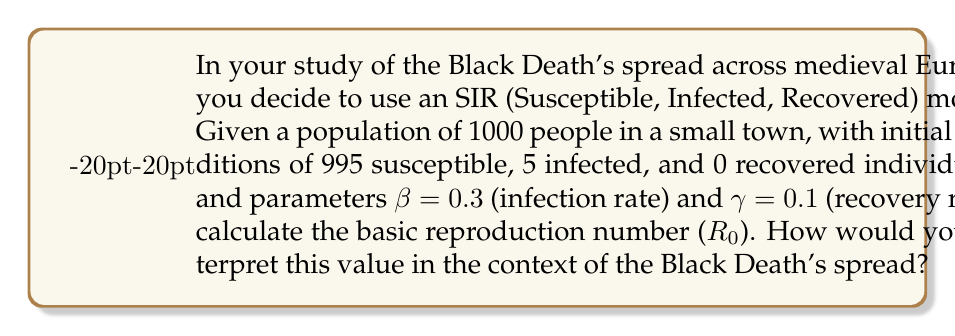Can you answer this question? To solve this problem, we'll follow these steps:

1. Understand the SIR model parameters:
   - S: Susceptible individuals
   - I: Infected individuals
   - R: Recovered individuals
   - β: Infection rate
   - γ: Recovery rate

2. Recall the formula for the basic reproduction number (R₀):
   $$ R_0 = \frac{\beta}{\gamma} $$

3. Insert the given values into the formula:
   $$ R_0 = \frac{0.3}{0.1} $$

4. Calculate R₀:
   $$ R_0 = 3 $$

5. Interpret the result:
   - R₀ > 1 indicates that the disease will spread exponentially.
   - R₀ = 3 means that, on average, each infected person will infect 3 new individuals during their infectious period.
   - This high R₀ value aligns with the historical rapid spread of the Black Death across Europe.
   - It suggests that without intervention, the disease would quickly spread through the population.
   - This model helps explain why the Black Death was so devastating and difficult to control in medieval times, given the lack of modern medical knowledge and interventions.
Answer: R₀ = 3; indicates rapid, exponential spread 